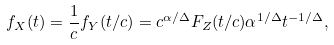Convert formula to latex. <formula><loc_0><loc_0><loc_500><loc_500>f _ { X } ( t ) = \frac { 1 } { c } f _ { Y } ( t / c ) = c ^ { \alpha / \Delta } F _ { Z } ( t / c ) \alpha ^ { 1 / \Delta } t ^ { - 1 / \Delta } ,</formula> 